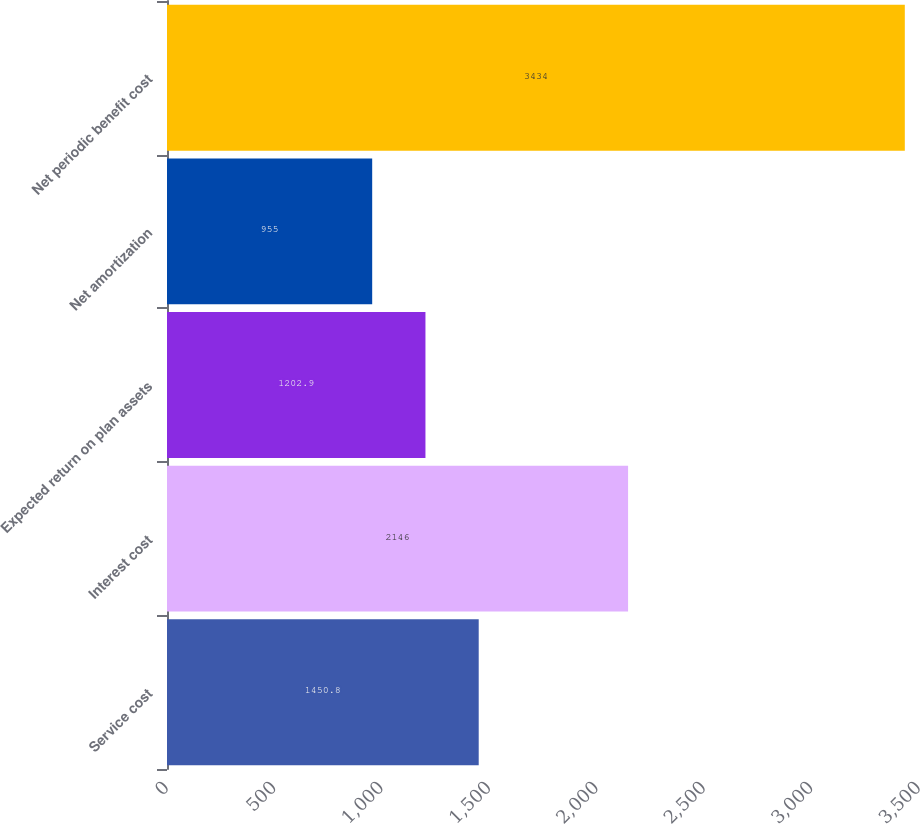Convert chart. <chart><loc_0><loc_0><loc_500><loc_500><bar_chart><fcel>Service cost<fcel>Interest cost<fcel>Expected return on plan assets<fcel>Net amortization<fcel>Net periodic benefit cost<nl><fcel>1450.8<fcel>2146<fcel>1202.9<fcel>955<fcel>3434<nl></chart> 